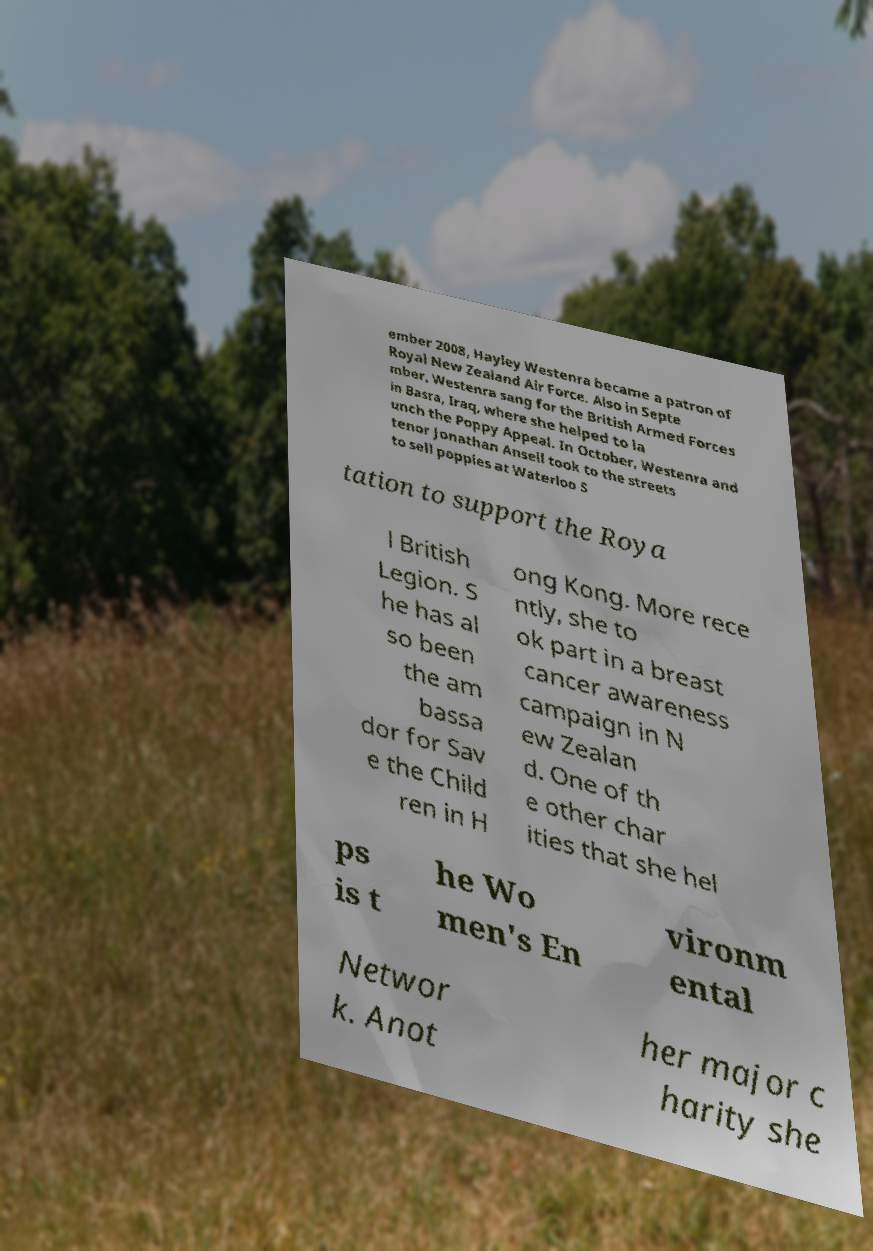What messages or text are displayed in this image? I need them in a readable, typed format. ember 2008, Hayley Westenra became a patron of Royal New Zealand Air Force. Also in Septe mber, Westenra sang for the British Armed Forces in Basra, Iraq, where she helped to la unch the Poppy Appeal. In October, Westenra and tenor Jonathan Ansell took to the streets to sell poppies at Waterloo S tation to support the Roya l British Legion. S he has al so been the am bassa dor for Sav e the Child ren in H ong Kong. More rece ntly, she to ok part in a breast cancer awareness campaign in N ew Zealan d. One of th e other char ities that she hel ps is t he Wo men's En vironm ental Networ k. Anot her major c harity she 